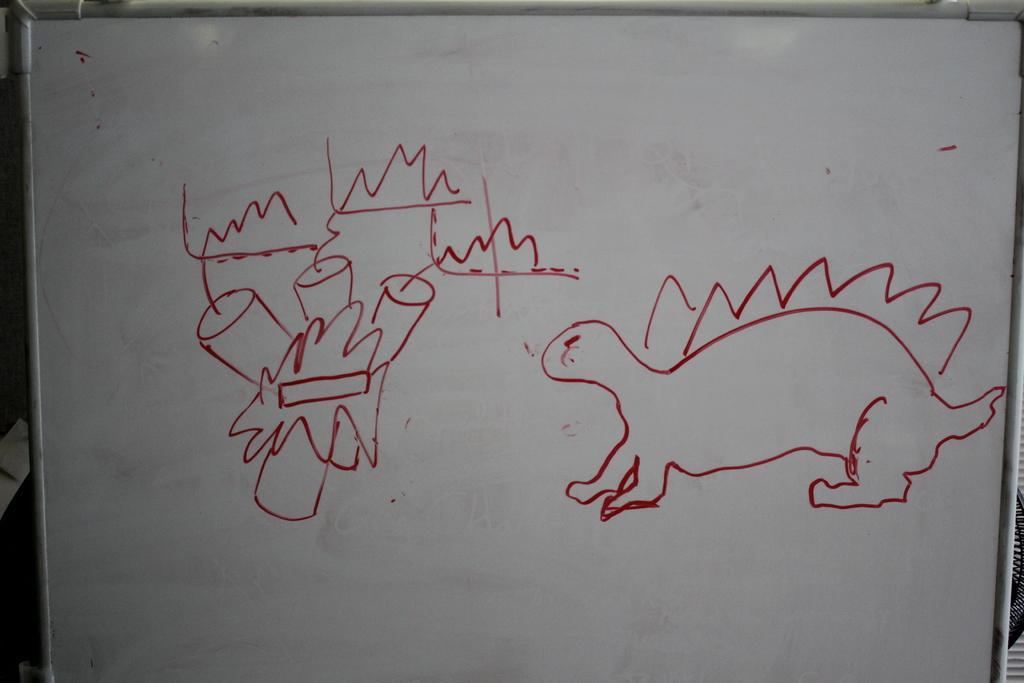In one or two sentences, can you explain what this image depicts? In this image I can see a board with some drawings on it. In the background there are few objects. 